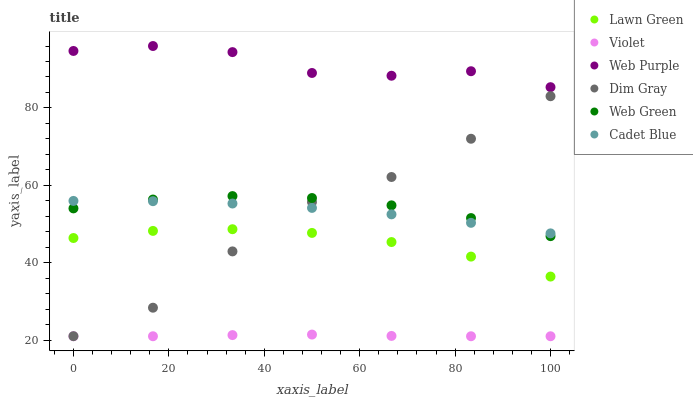Does Violet have the minimum area under the curve?
Answer yes or no. Yes. Does Web Purple have the maximum area under the curve?
Answer yes or no. Yes. Does Cadet Blue have the minimum area under the curve?
Answer yes or no. No. Does Cadet Blue have the maximum area under the curve?
Answer yes or no. No. Is Violet the smoothest?
Answer yes or no. Yes. Is Dim Gray the roughest?
Answer yes or no. Yes. Is Cadet Blue the smoothest?
Answer yes or no. No. Is Cadet Blue the roughest?
Answer yes or no. No. Does Violet have the lowest value?
Answer yes or no. Yes. Does Cadet Blue have the lowest value?
Answer yes or no. No. Does Web Purple have the highest value?
Answer yes or no. Yes. Does Cadet Blue have the highest value?
Answer yes or no. No. Is Violet less than Web Green?
Answer yes or no. Yes. Is Dim Gray greater than Violet?
Answer yes or no. Yes. Does Dim Gray intersect Web Green?
Answer yes or no. Yes. Is Dim Gray less than Web Green?
Answer yes or no. No. Is Dim Gray greater than Web Green?
Answer yes or no. No. Does Violet intersect Web Green?
Answer yes or no. No. 